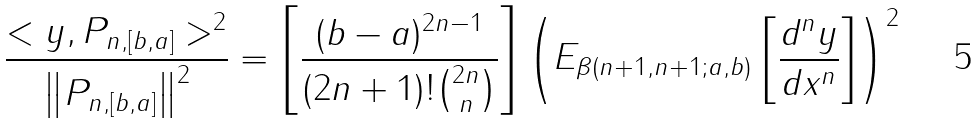<formula> <loc_0><loc_0><loc_500><loc_500>\frac { < y , P _ { n , [ b , a ] } > ^ { 2 } } { \left \| P _ { n , [ b , a ] } \right \| ^ { 2 } } = \left [ \frac { ( b - a ) ^ { 2 n - 1 } } { ( 2 n + 1 ) ! { 2 n \choose n } } \right ] \left ( E _ { \beta ( n + 1 , n + 1 ; a , b ) } \left [ \frac { d ^ { n } y } { d x ^ { n } } \right ] \right ) ^ { 2 }</formula> 